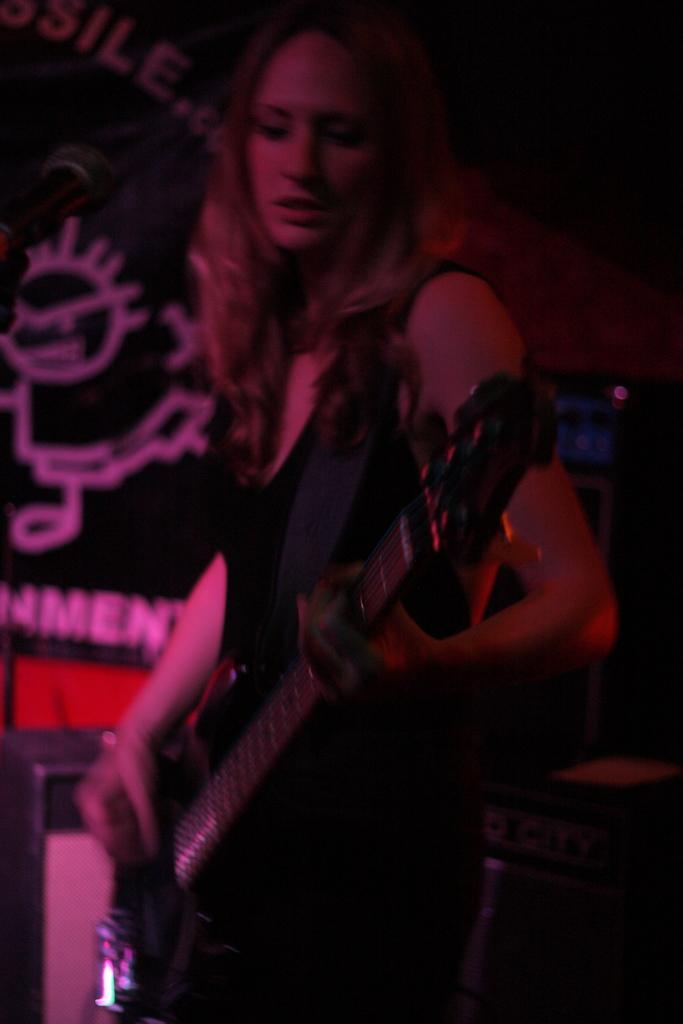Who is the main subject in the image? There is a woman in the image. What is the woman holding in the image? The woman is holding a guitar. What might the woman be doing with the guitar? The woman may be playing the guitar. What type of soap is the woman using to clean the guitar in the image? There is no soap or cleaning activity depicted in the image; the woman is simply holding a guitar. 